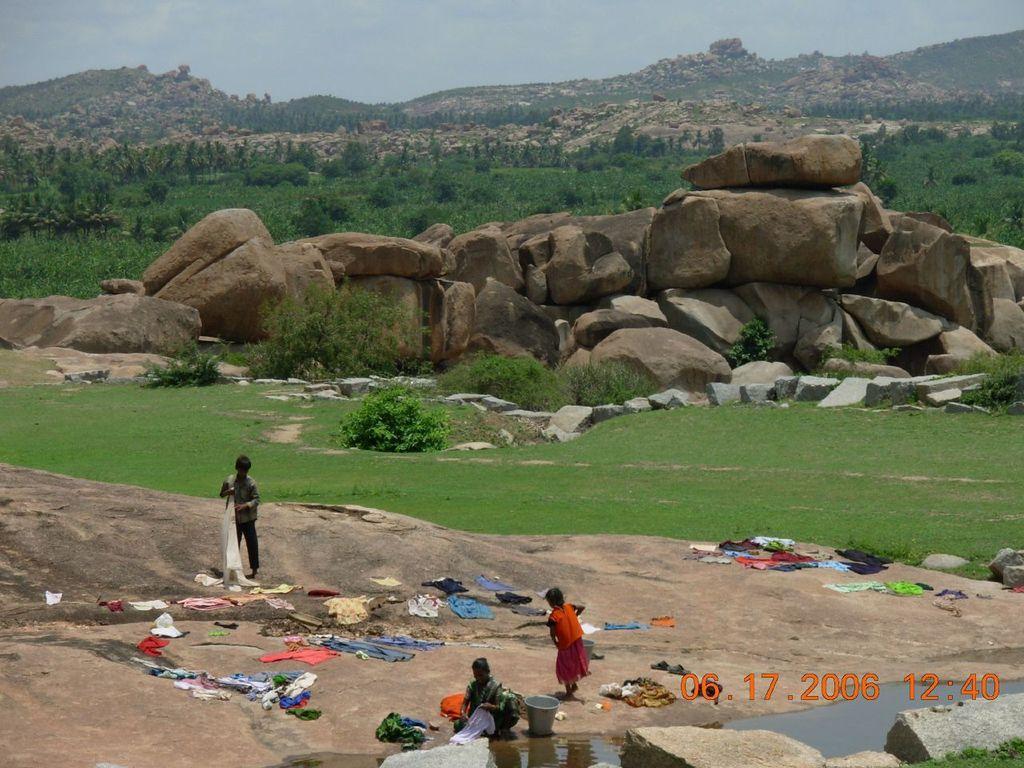Can you describe this image briefly? In the picture I can see people on the ground. I can also see clothes, the grass, plants, the water and other objects on the ground. In the background I can see trees, hills and the sky. 